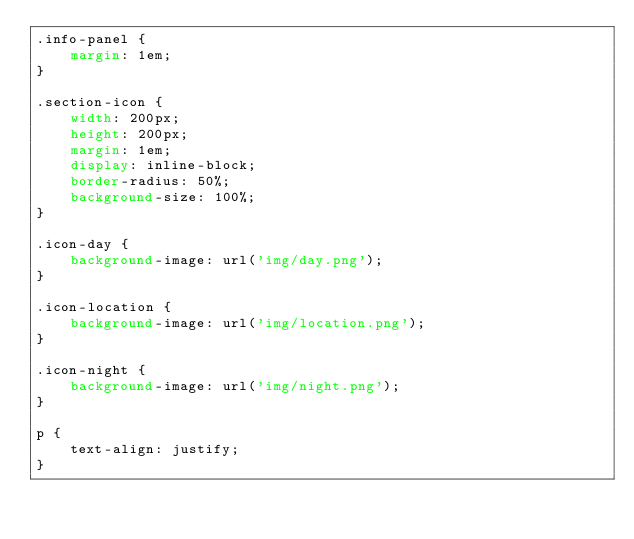<code> <loc_0><loc_0><loc_500><loc_500><_CSS_>.info-panel {
    margin: 1em;
}

.section-icon {
    width: 200px;
    height: 200px;
    margin: 1em;
    display: inline-block;
    border-radius: 50%;
    background-size: 100%;
}

.icon-day {
    background-image: url('img/day.png');
}

.icon-location {
    background-image: url('img/location.png');
}

.icon-night {
    background-image: url('img/night.png');
}

p {
    text-align: justify;
}</code> 